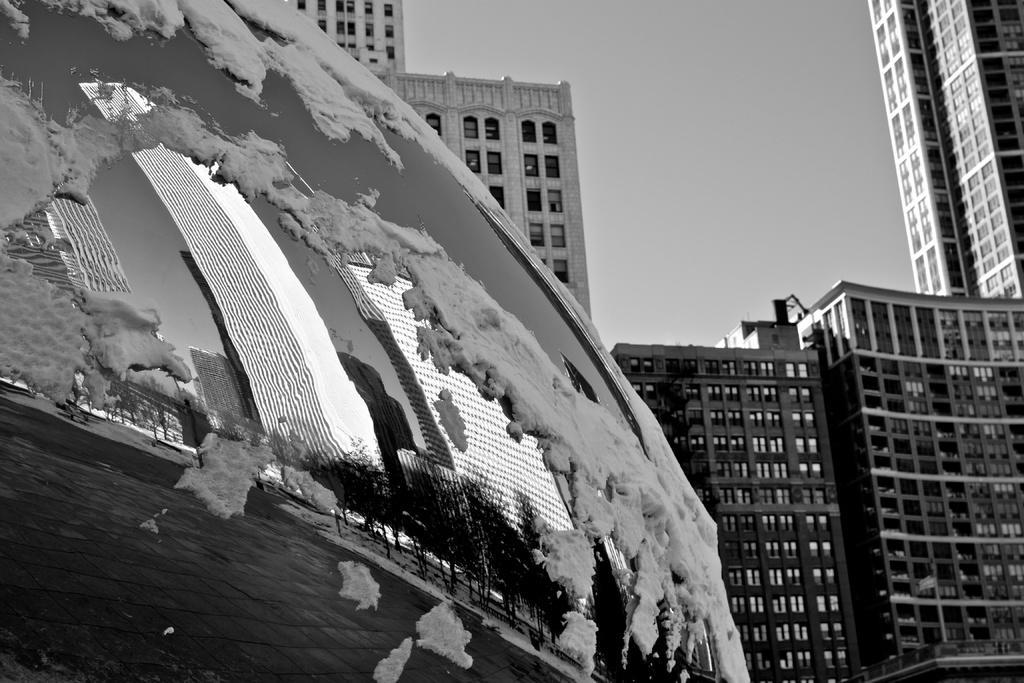Please provide a concise description of this image. In the picture we can see a part of a glass substance with snow on it and on it we can see a image of some buildings, water and trees and behind the substance we can see some tower buildings with many floors, windows to it with glasses and behind it we can see a sky. 